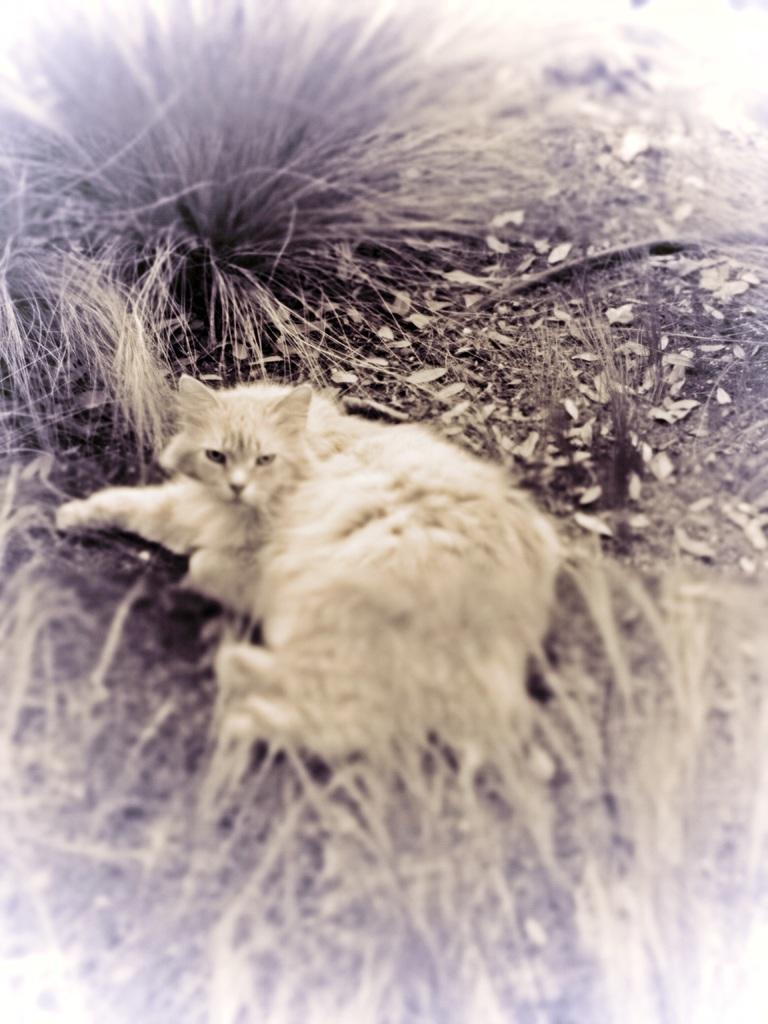Could you give a brief overview of what you see in this image? In this picture we can see a cat laying here, at the bottom there is grass, we can see some leaves here. 